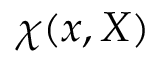<formula> <loc_0><loc_0><loc_500><loc_500>\chi ( x , X )</formula> 